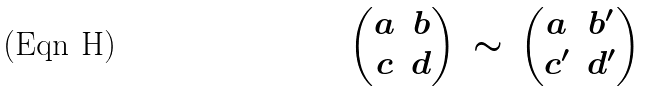<formula> <loc_0><loc_0><loc_500><loc_500>\begin{pmatrix} a & b \\ c & d \end{pmatrix} \, \sim \, \begin{pmatrix} a & b ^ { \prime } \\ c ^ { \prime } & d ^ { \prime } \end{pmatrix}</formula> 